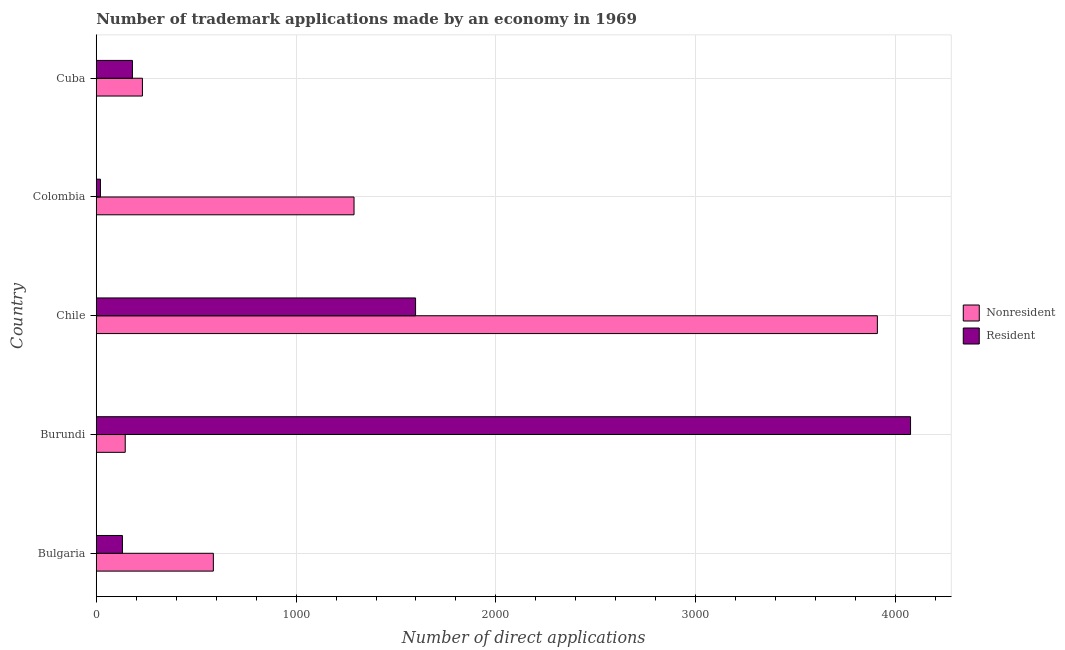How many different coloured bars are there?
Give a very brief answer. 2. Are the number of bars per tick equal to the number of legend labels?
Provide a succinct answer. Yes. Are the number of bars on each tick of the Y-axis equal?
Offer a terse response. Yes. What is the label of the 1st group of bars from the top?
Give a very brief answer. Cuba. In how many cases, is the number of bars for a given country not equal to the number of legend labels?
Provide a succinct answer. 0. What is the number of trademark applications made by residents in Colombia?
Provide a succinct answer. 21. Across all countries, what is the maximum number of trademark applications made by non residents?
Give a very brief answer. 3909. Across all countries, what is the minimum number of trademark applications made by non residents?
Make the answer very short. 145. In which country was the number of trademark applications made by residents minimum?
Provide a succinct answer. Colombia. What is the total number of trademark applications made by residents in the graph?
Ensure brevity in your answer.  6006. What is the difference between the number of trademark applications made by non residents in Burundi and that in Chile?
Your answer should be compact. -3764. What is the difference between the number of trademark applications made by residents in Burundi and the number of trademark applications made by non residents in Colombia?
Ensure brevity in your answer.  2785. What is the average number of trademark applications made by residents per country?
Keep it short and to the point. 1201.2. What is the difference between the number of trademark applications made by residents and number of trademark applications made by non residents in Burundi?
Your response must be concise. 3930. In how many countries, is the number of trademark applications made by residents greater than 600 ?
Provide a succinct answer. 2. What is the ratio of the number of trademark applications made by non residents in Bulgaria to that in Cuba?
Make the answer very short. 2.54. Is the number of trademark applications made by non residents in Bulgaria less than that in Colombia?
Give a very brief answer. Yes. What is the difference between the highest and the second highest number of trademark applications made by non residents?
Your answer should be compact. 2619. What is the difference between the highest and the lowest number of trademark applications made by non residents?
Your response must be concise. 3764. Is the sum of the number of trademark applications made by non residents in Bulgaria and Colombia greater than the maximum number of trademark applications made by residents across all countries?
Ensure brevity in your answer.  No. What does the 2nd bar from the top in Colombia represents?
Provide a short and direct response. Nonresident. What does the 2nd bar from the bottom in Cuba represents?
Your response must be concise. Resident. Are all the bars in the graph horizontal?
Your answer should be compact. Yes. How many countries are there in the graph?
Provide a short and direct response. 5. What is the difference between two consecutive major ticks on the X-axis?
Offer a very short reply. 1000. Does the graph contain any zero values?
Keep it short and to the point. No. What is the title of the graph?
Offer a very short reply. Number of trademark applications made by an economy in 1969. What is the label or title of the X-axis?
Give a very brief answer. Number of direct applications. What is the label or title of the Y-axis?
Ensure brevity in your answer.  Country. What is the Number of direct applications of Nonresident in Bulgaria?
Make the answer very short. 586. What is the Number of direct applications of Resident in Bulgaria?
Your answer should be very brief. 131. What is the Number of direct applications of Nonresident in Burundi?
Offer a terse response. 145. What is the Number of direct applications in Resident in Burundi?
Offer a very short reply. 4075. What is the Number of direct applications in Nonresident in Chile?
Provide a short and direct response. 3909. What is the Number of direct applications of Resident in Chile?
Provide a short and direct response. 1598. What is the Number of direct applications in Nonresident in Colombia?
Provide a short and direct response. 1290. What is the Number of direct applications of Nonresident in Cuba?
Provide a short and direct response. 231. What is the Number of direct applications of Resident in Cuba?
Ensure brevity in your answer.  181. Across all countries, what is the maximum Number of direct applications of Nonresident?
Offer a very short reply. 3909. Across all countries, what is the maximum Number of direct applications in Resident?
Provide a succinct answer. 4075. Across all countries, what is the minimum Number of direct applications in Nonresident?
Provide a short and direct response. 145. What is the total Number of direct applications of Nonresident in the graph?
Ensure brevity in your answer.  6161. What is the total Number of direct applications of Resident in the graph?
Your response must be concise. 6006. What is the difference between the Number of direct applications of Nonresident in Bulgaria and that in Burundi?
Keep it short and to the point. 441. What is the difference between the Number of direct applications of Resident in Bulgaria and that in Burundi?
Your answer should be very brief. -3944. What is the difference between the Number of direct applications of Nonresident in Bulgaria and that in Chile?
Offer a very short reply. -3323. What is the difference between the Number of direct applications in Resident in Bulgaria and that in Chile?
Offer a terse response. -1467. What is the difference between the Number of direct applications in Nonresident in Bulgaria and that in Colombia?
Provide a succinct answer. -704. What is the difference between the Number of direct applications of Resident in Bulgaria and that in Colombia?
Your answer should be very brief. 110. What is the difference between the Number of direct applications in Nonresident in Bulgaria and that in Cuba?
Your response must be concise. 355. What is the difference between the Number of direct applications in Nonresident in Burundi and that in Chile?
Keep it short and to the point. -3764. What is the difference between the Number of direct applications in Resident in Burundi and that in Chile?
Your response must be concise. 2477. What is the difference between the Number of direct applications in Nonresident in Burundi and that in Colombia?
Your response must be concise. -1145. What is the difference between the Number of direct applications in Resident in Burundi and that in Colombia?
Your answer should be compact. 4054. What is the difference between the Number of direct applications in Nonresident in Burundi and that in Cuba?
Ensure brevity in your answer.  -86. What is the difference between the Number of direct applications in Resident in Burundi and that in Cuba?
Your answer should be very brief. 3894. What is the difference between the Number of direct applications of Nonresident in Chile and that in Colombia?
Give a very brief answer. 2619. What is the difference between the Number of direct applications in Resident in Chile and that in Colombia?
Provide a succinct answer. 1577. What is the difference between the Number of direct applications in Nonresident in Chile and that in Cuba?
Ensure brevity in your answer.  3678. What is the difference between the Number of direct applications of Resident in Chile and that in Cuba?
Your answer should be compact. 1417. What is the difference between the Number of direct applications of Nonresident in Colombia and that in Cuba?
Make the answer very short. 1059. What is the difference between the Number of direct applications in Resident in Colombia and that in Cuba?
Offer a terse response. -160. What is the difference between the Number of direct applications of Nonresident in Bulgaria and the Number of direct applications of Resident in Burundi?
Your answer should be compact. -3489. What is the difference between the Number of direct applications of Nonresident in Bulgaria and the Number of direct applications of Resident in Chile?
Offer a terse response. -1012. What is the difference between the Number of direct applications in Nonresident in Bulgaria and the Number of direct applications in Resident in Colombia?
Make the answer very short. 565. What is the difference between the Number of direct applications in Nonresident in Bulgaria and the Number of direct applications in Resident in Cuba?
Your answer should be very brief. 405. What is the difference between the Number of direct applications in Nonresident in Burundi and the Number of direct applications in Resident in Chile?
Provide a succinct answer. -1453. What is the difference between the Number of direct applications in Nonresident in Burundi and the Number of direct applications in Resident in Colombia?
Give a very brief answer. 124. What is the difference between the Number of direct applications in Nonresident in Burundi and the Number of direct applications in Resident in Cuba?
Offer a terse response. -36. What is the difference between the Number of direct applications of Nonresident in Chile and the Number of direct applications of Resident in Colombia?
Provide a succinct answer. 3888. What is the difference between the Number of direct applications of Nonresident in Chile and the Number of direct applications of Resident in Cuba?
Your response must be concise. 3728. What is the difference between the Number of direct applications of Nonresident in Colombia and the Number of direct applications of Resident in Cuba?
Give a very brief answer. 1109. What is the average Number of direct applications in Nonresident per country?
Keep it short and to the point. 1232.2. What is the average Number of direct applications in Resident per country?
Ensure brevity in your answer.  1201.2. What is the difference between the Number of direct applications in Nonresident and Number of direct applications in Resident in Bulgaria?
Offer a terse response. 455. What is the difference between the Number of direct applications in Nonresident and Number of direct applications in Resident in Burundi?
Provide a succinct answer. -3930. What is the difference between the Number of direct applications of Nonresident and Number of direct applications of Resident in Chile?
Offer a terse response. 2311. What is the difference between the Number of direct applications of Nonresident and Number of direct applications of Resident in Colombia?
Provide a succinct answer. 1269. What is the difference between the Number of direct applications in Nonresident and Number of direct applications in Resident in Cuba?
Make the answer very short. 50. What is the ratio of the Number of direct applications of Nonresident in Bulgaria to that in Burundi?
Your response must be concise. 4.04. What is the ratio of the Number of direct applications in Resident in Bulgaria to that in Burundi?
Your answer should be very brief. 0.03. What is the ratio of the Number of direct applications in Nonresident in Bulgaria to that in Chile?
Provide a succinct answer. 0.15. What is the ratio of the Number of direct applications of Resident in Bulgaria to that in Chile?
Your answer should be compact. 0.08. What is the ratio of the Number of direct applications in Nonresident in Bulgaria to that in Colombia?
Offer a very short reply. 0.45. What is the ratio of the Number of direct applications of Resident in Bulgaria to that in Colombia?
Offer a very short reply. 6.24. What is the ratio of the Number of direct applications of Nonresident in Bulgaria to that in Cuba?
Your answer should be compact. 2.54. What is the ratio of the Number of direct applications in Resident in Bulgaria to that in Cuba?
Provide a succinct answer. 0.72. What is the ratio of the Number of direct applications in Nonresident in Burundi to that in Chile?
Provide a short and direct response. 0.04. What is the ratio of the Number of direct applications of Resident in Burundi to that in Chile?
Make the answer very short. 2.55. What is the ratio of the Number of direct applications of Nonresident in Burundi to that in Colombia?
Give a very brief answer. 0.11. What is the ratio of the Number of direct applications of Resident in Burundi to that in Colombia?
Give a very brief answer. 194.05. What is the ratio of the Number of direct applications of Nonresident in Burundi to that in Cuba?
Your answer should be very brief. 0.63. What is the ratio of the Number of direct applications in Resident in Burundi to that in Cuba?
Offer a terse response. 22.51. What is the ratio of the Number of direct applications of Nonresident in Chile to that in Colombia?
Provide a short and direct response. 3.03. What is the ratio of the Number of direct applications of Resident in Chile to that in Colombia?
Offer a terse response. 76.1. What is the ratio of the Number of direct applications of Nonresident in Chile to that in Cuba?
Your answer should be compact. 16.92. What is the ratio of the Number of direct applications in Resident in Chile to that in Cuba?
Keep it short and to the point. 8.83. What is the ratio of the Number of direct applications of Nonresident in Colombia to that in Cuba?
Offer a terse response. 5.58. What is the ratio of the Number of direct applications in Resident in Colombia to that in Cuba?
Give a very brief answer. 0.12. What is the difference between the highest and the second highest Number of direct applications of Nonresident?
Provide a short and direct response. 2619. What is the difference between the highest and the second highest Number of direct applications of Resident?
Your answer should be very brief. 2477. What is the difference between the highest and the lowest Number of direct applications of Nonresident?
Make the answer very short. 3764. What is the difference between the highest and the lowest Number of direct applications in Resident?
Ensure brevity in your answer.  4054. 